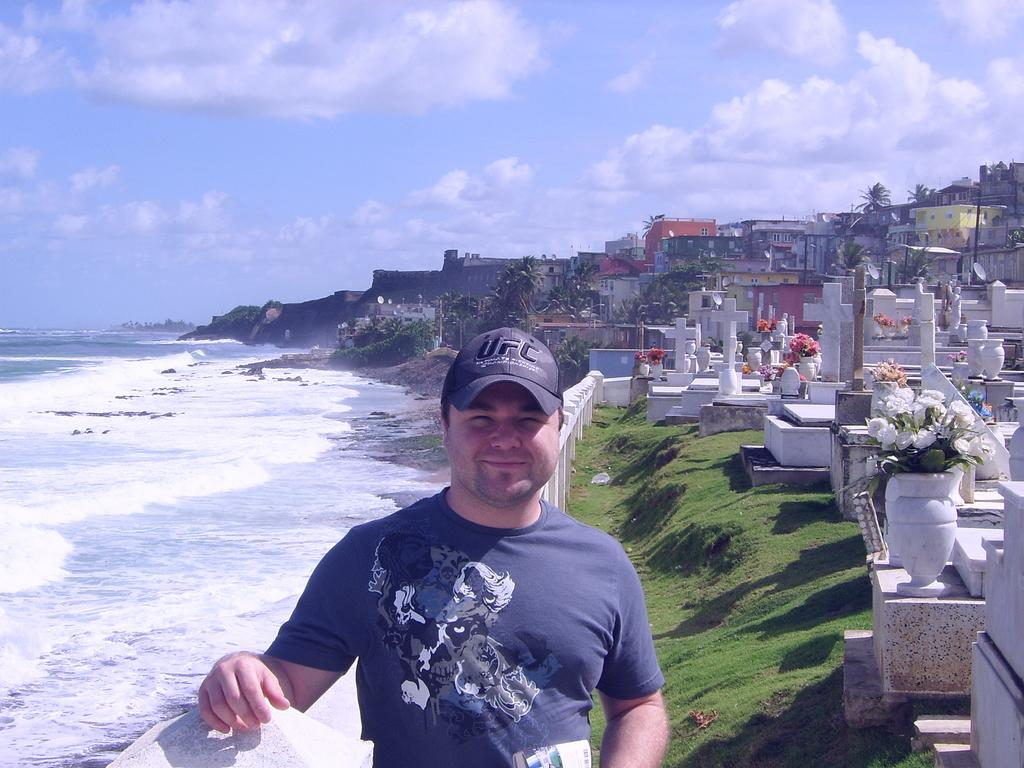What type of location is depicted on the right side of the image? There is a graveyard on the right side of the image. What can be seen in the middle of the image? There is a man standing in the middle of the image. What is visible on the left side of the image? There is water visible on the left side of the image. What is visible at the top of the image? The sky is visible at the top of the image. What type of food is being served on the tray in the image? There is no tray or food present in the image. How many babies are visible in the image? There are no babies present in the image. 